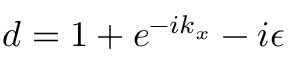<formula> <loc_0><loc_0><loc_500><loc_500>d = 1 + e ^ { - i k _ { x } } - i \epsilon</formula> 